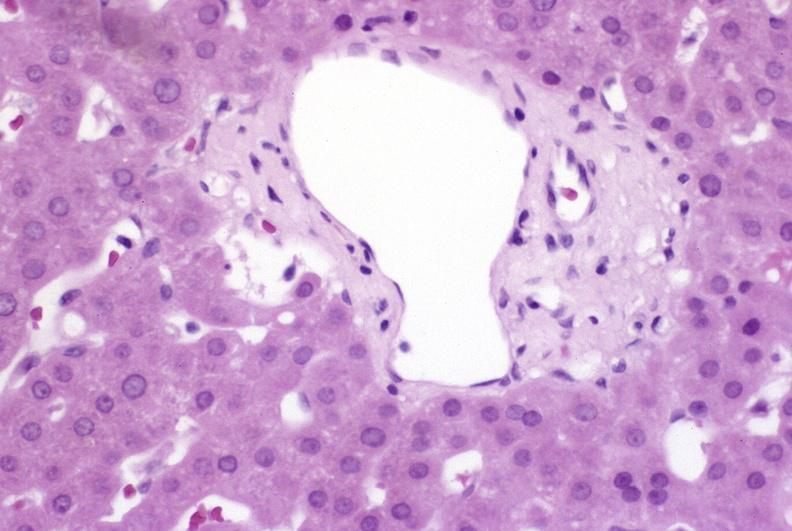s hepatobiliary present?
Answer the question using a single word or phrase. Yes 